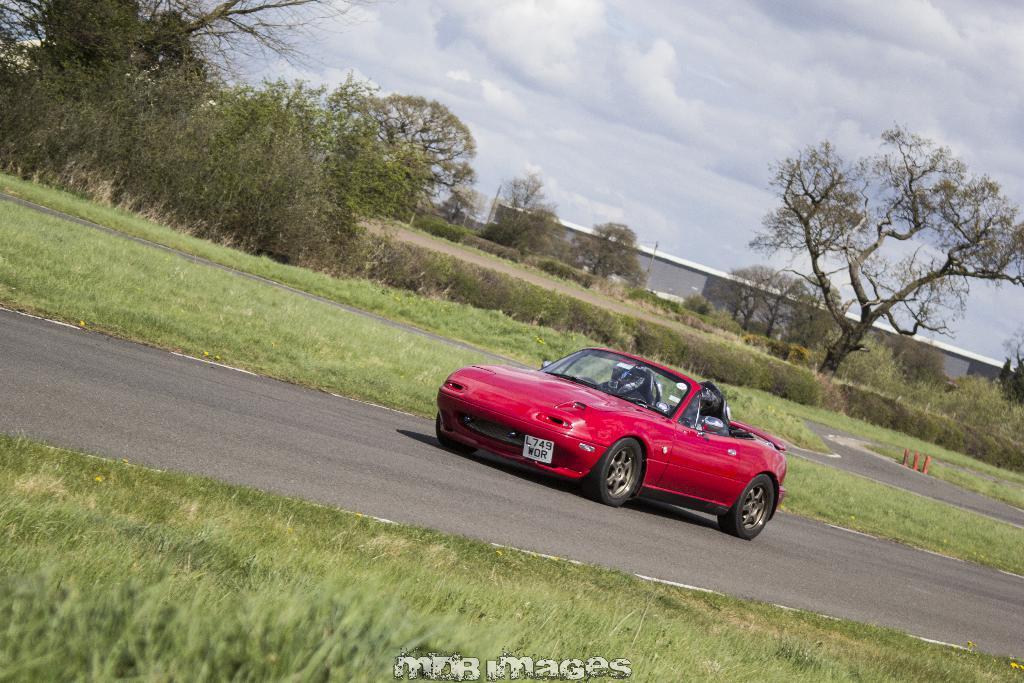In one or two sentences, can you explain what this image depicts? In the center of the image there is a car on the road. At the bottom there is a grass and text. In the background we can see road, trees, building, plants, sky and clouds. 